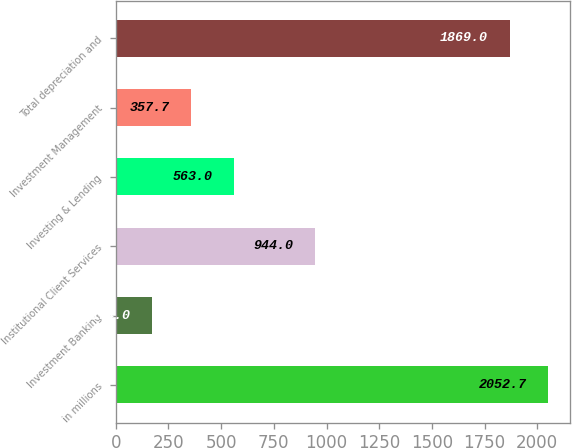<chart> <loc_0><loc_0><loc_500><loc_500><bar_chart><fcel>in millions<fcel>Investment Banking<fcel>Institutional Client Services<fcel>Investing & Lending<fcel>Investment Management<fcel>Total depreciation and<nl><fcel>2052.7<fcel>174<fcel>944<fcel>563<fcel>357.7<fcel>1869<nl></chart> 